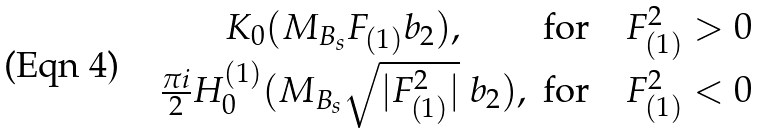Convert formula to latex. <formula><loc_0><loc_0><loc_500><loc_500>\begin{matrix} K _ { 0 } ( M _ { B _ { s } } F _ { ( 1 ) } b _ { 2 } ) , & \text {for} \quad F ^ { 2 } _ { ( 1 ) } > 0 \\ \frac { \pi i } { 2 } H _ { 0 } ^ { ( 1 ) } ( M _ { B _ { s } } \sqrt { | F ^ { 2 } _ { ( 1 ) } | } \ b _ { 2 } ) , & \text {for} \quad F ^ { 2 } _ { ( 1 ) } < 0 \end{matrix}</formula> 